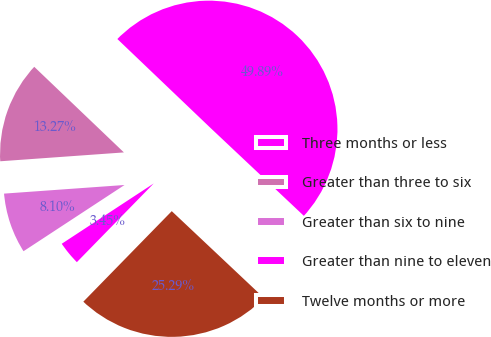Convert chart to OTSL. <chart><loc_0><loc_0><loc_500><loc_500><pie_chart><fcel>Three months or less<fcel>Greater than three to six<fcel>Greater than six to nine<fcel>Greater than nine to eleven<fcel>Twelve months or more<nl><fcel>49.89%<fcel>13.27%<fcel>8.1%<fcel>3.45%<fcel>25.29%<nl></chart> 